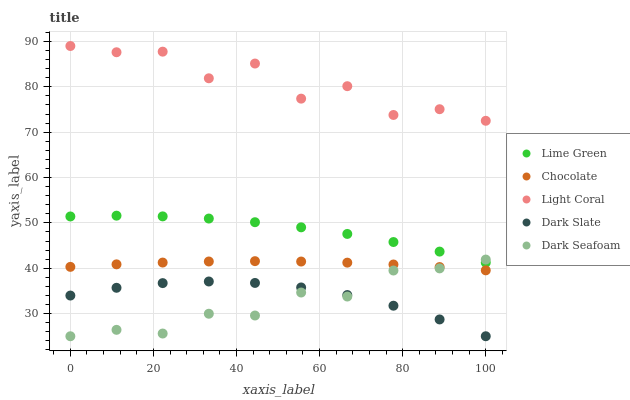Does Dark Seafoam have the minimum area under the curve?
Answer yes or no. Yes. Does Light Coral have the maximum area under the curve?
Answer yes or no. Yes. Does Dark Slate have the minimum area under the curve?
Answer yes or no. No. Does Dark Slate have the maximum area under the curve?
Answer yes or no. No. Is Chocolate the smoothest?
Answer yes or no. Yes. Is Light Coral the roughest?
Answer yes or no. Yes. Is Dark Slate the smoothest?
Answer yes or no. No. Is Dark Slate the roughest?
Answer yes or no. No. Does Dark Seafoam have the lowest value?
Answer yes or no. Yes. Does Dark Slate have the lowest value?
Answer yes or no. No. Does Light Coral have the highest value?
Answer yes or no. Yes. Does Dark Seafoam have the highest value?
Answer yes or no. No. Is Dark Slate less than Chocolate?
Answer yes or no. Yes. Is Chocolate greater than Dark Slate?
Answer yes or no. Yes. Does Dark Seafoam intersect Lime Green?
Answer yes or no. Yes. Is Dark Seafoam less than Lime Green?
Answer yes or no. No. Is Dark Seafoam greater than Lime Green?
Answer yes or no. No. Does Dark Slate intersect Chocolate?
Answer yes or no. No. 